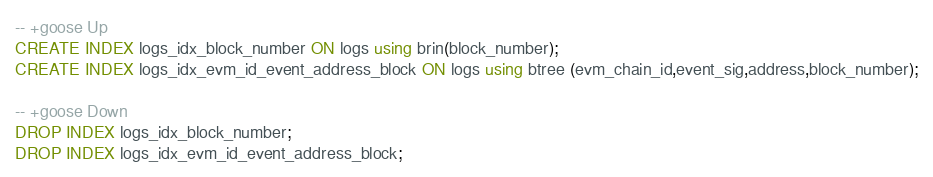Convert code to text. <code><loc_0><loc_0><loc_500><loc_500><_SQL_>-- +goose Up
CREATE INDEX logs_idx_block_number ON logs using brin(block_number);
CREATE INDEX logs_idx_evm_id_event_address_block ON logs using btree (evm_chain_id,event_sig,address,block_number);

-- +goose Down
DROP INDEX logs_idx_block_number;
DROP INDEX logs_idx_evm_id_event_address_block;
</code> 